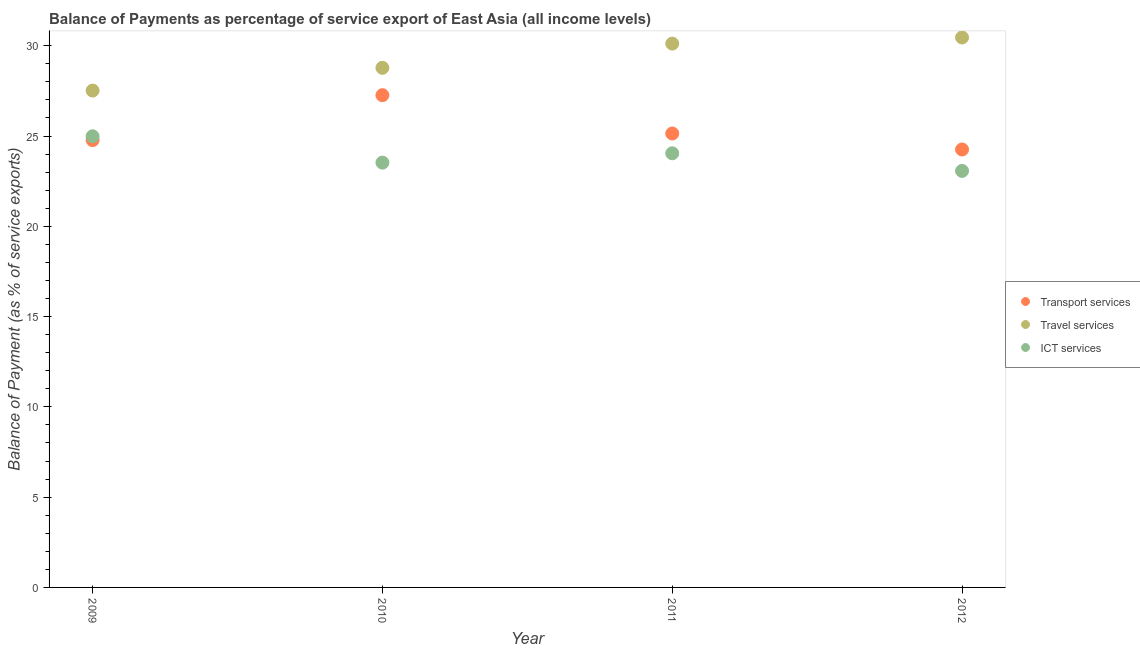How many different coloured dotlines are there?
Your answer should be very brief. 3. Is the number of dotlines equal to the number of legend labels?
Keep it short and to the point. Yes. What is the balance of payment of ict services in 2011?
Make the answer very short. 24.04. Across all years, what is the maximum balance of payment of travel services?
Your answer should be very brief. 30.46. Across all years, what is the minimum balance of payment of travel services?
Provide a short and direct response. 27.51. What is the total balance of payment of ict services in the graph?
Offer a very short reply. 95.62. What is the difference between the balance of payment of ict services in 2010 and that in 2011?
Your answer should be very brief. -0.52. What is the difference between the balance of payment of travel services in 2010 and the balance of payment of transport services in 2012?
Make the answer very short. 4.52. What is the average balance of payment of transport services per year?
Offer a terse response. 25.36. In the year 2009, what is the difference between the balance of payment of travel services and balance of payment of ict services?
Give a very brief answer. 2.53. In how many years, is the balance of payment of travel services greater than 11 %?
Offer a terse response. 4. What is the ratio of the balance of payment of ict services in 2009 to that in 2011?
Offer a terse response. 1.04. Is the balance of payment of ict services in 2011 less than that in 2012?
Ensure brevity in your answer.  No. What is the difference between the highest and the second highest balance of payment of travel services?
Give a very brief answer. 0.34. What is the difference between the highest and the lowest balance of payment of travel services?
Your answer should be very brief. 2.94. Is the sum of the balance of payment of transport services in 2010 and 2011 greater than the maximum balance of payment of ict services across all years?
Your answer should be very brief. Yes. Is it the case that in every year, the sum of the balance of payment of transport services and balance of payment of travel services is greater than the balance of payment of ict services?
Provide a short and direct response. Yes. Does the balance of payment of ict services monotonically increase over the years?
Your answer should be compact. No. Is the balance of payment of travel services strictly greater than the balance of payment of ict services over the years?
Your response must be concise. Yes. How many years are there in the graph?
Your answer should be compact. 4. What is the difference between two consecutive major ticks on the Y-axis?
Offer a very short reply. 5. Are the values on the major ticks of Y-axis written in scientific E-notation?
Your response must be concise. No. What is the title of the graph?
Make the answer very short. Balance of Payments as percentage of service export of East Asia (all income levels). Does "Tertiary" appear as one of the legend labels in the graph?
Ensure brevity in your answer.  No. What is the label or title of the X-axis?
Provide a short and direct response. Year. What is the label or title of the Y-axis?
Provide a succinct answer. Balance of Payment (as % of service exports). What is the Balance of Payment (as % of service exports) of Transport services in 2009?
Give a very brief answer. 24.77. What is the Balance of Payment (as % of service exports) of Travel services in 2009?
Your response must be concise. 27.51. What is the Balance of Payment (as % of service exports) in ICT services in 2009?
Keep it short and to the point. 24.98. What is the Balance of Payment (as % of service exports) in Transport services in 2010?
Ensure brevity in your answer.  27.26. What is the Balance of Payment (as % of service exports) of Travel services in 2010?
Keep it short and to the point. 28.78. What is the Balance of Payment (as % of service exports) of ICT services in 2010?
Ensure brevity in your answer.  23.53. What is the Balance of Payment (as % of service exports) of Transport services in 2011?
Ensure brevity in your answer.  25.14. What is the Balance of Payment (as % of service exports) of Travel services in 2011?
Keep it short and to the point. 30.12. What is the Balance of Payment (as % of service exports) of ICT services in 2011?
Ensure brevity in your answer.  24.04. What is the Balance of Payment (as % of service exports) of Transport services in 2012?
Your answer should be compact. 24.25. What is the Balance of Payment (as % of service exports) in Travel services in 2012?
Give a very brief answer. 30.46. What is the Balance of Payment (as % of service exports) of ICT services in 2012?
Your answer should be very brief. 23.07. Across all years, what is the maximum Balance of Payment (as % of service exports) of Transport services?
Your response must be concise. 27.26. Across all years, what is the maximum Balance of Payment (as % of service exports) of Travel services?
Your answer should be compact. 30.46. Across all years, what is the maximum Balance of Payment (as % of service exports) in ICT services?
Give a very brief answer. 24.98. Across all years, what is the minimum Balance of Payment (as % of service exports) of Transport services?
Your answer should be compact. 24.25. Across all years, what is the minimum Balance of Payment (as % of service exports) in Travel services?
Offer a terse response. 27.51. Across all years, what is the minimum Balance of Payment (as % of service exports) of ICT services?
Provide a short and direct response. 23.07. What is the total Balance of Payment (as % of service exports) of Transport services in the graph?
Make the answer very short. 101.43. What is the total Balance of Payment (as % of service exports) of Travel services in the graph?
Your answer should be compact. 116.86. What is the total Balance of Payment (as % of service exports) of ICT services in the graph?
Ensure brevity in your answer.  95.62. What is the difference between the Balance of Payment (as % of service exports) of Transport services in 2009 and that in 2010?
Provide a short and direct response. -2.49. What is the difference between the Balance of Payment (as % of service exports) of Travel services in 2009 and that in 2010?
Offer a terse response. -1.26. What is the difference between the Balance of Payment (as % of service exports) in ICT services in 2009 and that in 2010?
Offer a terse response. 1.46. What is the difference between the Balance of Payment (as % of service exports) in Transport services in 2009 and that in 2011?
Your answer should be very brief. -0.37. What is the difference between the Balance of Payment (as % of service exports) in Travel services in 2009 and that in 2011?
Your answer should be compact. -2.6. What is the difference between the Balance of Payment (as % of service exports) of ICT services in 2009 and that in 2011?
Your answer should be compact. 0.94. What is the difference between the Balance of Payment (as % of service exports) in Transport services in 2009 and that in 2012?
Offer a very short reply. 0.52. What is the difference between the Balance of Payment (as % of service exports) of Travel services in 2009 and that in 2012?
Your answer should be compact. -2.94. What is the difference between the Balance of Payment (as % of service exports) in ICT services in 2009 and that in 2012?
Offer a terse response. 1.92. What is the difference between the Balance of Payment (as % of service exports) in Transport services in 2010 and that in 2011?
Provide a short and direct response. 2.12. What is the difference between the Balance of Payment (as % of service exports) in Travel services in 2010 and that in 2011?
Ensure brevity in your answer.  -1.34. What is the difference between the Balance of Payment (as % of service exports) of ICT services in 2010 and that in 2011?
Offer a very short reply. -0.52. What is the difference between the Balance of Payment (as % of service exports) of Transport services in 2010 and that in 2012?
Your response must be concise. 3.01. What is the difference between the Balance of Payment (as % of service exports) in Travel services in 2010 and that in 2012?
Your answer should be compact. -1.68. What is the difference between the Balance of Payment (as % of service exports) of ICT services in 2010 and that in 2012?
Offer a very short reply. 0.46. What is the difference between the Balance of Payment (as % of service exports) in Transport services in 2011 and that in 2012?
Your answer should be very brief. 0.89. What is the difference between the Balance of Payment (as % of service exports) in Travel services in 2011 and that in 2012?
Offer a very short reply. -0.34. What is the difference between the Balance of Payment (as % of service exports) in ICT services in 2011 and that in 2012?
Keep it short and to the point. 0.98. What is the difference between the Balance of Payment (as % of service exports) of Transport services in 2009 and the Balance of Payment (as % of service exports) of Travel services in 2010?
Provide a short and direct response. -4. What is the difference between the Balance of Payment (as % of service exports) of Transport services in 2009 and the Balance of Payment (as % of service exports) of ICT services in 2010?
Provide a succinct answer. 1.25. What is the difference between the Balance of Payment (as % of service exports) of Travel services in 2009 and the Balance of Payment (as % of service exports) of ICT services in 2010?
Give a very brief answer. 3.99. What is the difference between the Balance of Payment (as % of service exports) in Transport services in 2009 and the Balance of Payment (as % of service exports) in Travel services in 2011?
Provide a succinct answer. -5.34. What is the difference between the Balance of Payment (as % of service exports) in Transport services in 2009 and the Balance of Payment (as % of service exports) in ICT services in 2011?
Provide a succinct answer. 0.73. What is the difference between the Balance of Payment (as % of service exports) of Travel services in 2009 and the Balance of Payment (as % of service exports) of ICT services in 2011?
Offer a terse response. 3.47. What is the difference between the Balance of Payment (as % of service exports) in Transport services in 2009 and the Balance of Payment (as % of service exports) in Travel services in 2012?
Make the answer very short. -5.68. What is the difference between the Balance of Payment (as % of service exports) of Transport services in 2009 and the Balance of Payment (as % of service exports) of ICT services in 2012?
Your answer should be compact. 1.71. What is the difference between the Balance of Payment (as % of service exports) of Travel services in 2009 and the Balance of Payment (as % of service exports) of ICT services in 2012?
Your response must be concise. 4.45. What is the difference between the Balance of Payment (as % of service exports) in Transport services in 2010 and the Balance of Payment (as % of service exports) in Travel services in 2011?
Offer a very short reply. -2.86. What is the difference between the Balance of Payment (as % of service exports) in Transport services in 2010 and the Balance of Payment (as % of service exports) in ICT services in 2011?
Offer a terse response. 3.22. What is the difference between the Balance of Payment (as % of service exports) in Travel services in 2010 and the Balance of Payment (as % of service exports) in ICT services in 2011?
Your response must be concise. 4.73. What is the difference between the Balance of Payment (as % of service exports) of Transport services in 2010 and the Balance of Payment (as % of service exports) of Travel services in 2012?
Make the answer very short. -3.19. What is the difference between the Balance of Payment (as % of service exports) of Transport services in 2010 and the Balance of Payment (as % of service exports) of ICT services in 2012?
Give a very brief answer. 4.19. What is the difference between the Balance of Payment (as % of service exports) of Travel services in 2010 and the Balance of Payment (as % of service exports) of ICT services in 2012?
Keep it short and to the point. 5.71. What is the difference between the Balance of Payment (as % of service exports) of Transport services in 2011 and the Balance of Payment (as % of service exports) of Travel services in 2012?
Provide a succinct answer. -5.32. What is the difference between the Balance of Payment (as % of service exports) in Transport services in 2011 and the Balance of Payment (as % of service exports) in ICT services in 2012?
Your answer should be compact. 2.07. What is the difference between the Balance of Payment (as % of service exports) in Travel services in 2011 and the Balance of Payment (as % of service exports) in ICT services in 2012?
Your answer should be very brief. 7.05. What is the average Balance of Payment (as % of service exports) of Transport services per year?
Your answer should be compact. 25.36. What is the average Balance of Payment (as % of service exports) in Travel services per year?
Offer a very short reply. 29.22. What is the average Balance of Payment (as % of service exports) of ICT services per year?
Your answer should be compact. 23.9. In the year 2009, what is the difference between the Balance of Payment (as % of service exports) in Transport services and Balance of Payment (as % of service exports) in Travel services?
Your answer should be compact. -2.74. In the year 2009, what is the difference between the Balance of Payment (as % of service exports) of Transport services and Balance of Payment (as % of service exports) of ICT services?
Ensure brevity in your answer.  -0.21. In the year 2009, what is the difference between the Balance of Payment (as % of service exports) of Travel services and Balance of Payment (as % of service exports) of ICT services?
Ensure brevity in your answer.  2.53. In the year 2010, what is the difference between the Balance of Payment (as % of service exports) of Transport services and Balance of Payment (as % of service exports) of Travel services?
Give a very brief answer. -1.51. In the year 2010, what is the difference between the Balance of Payment (as % of service exports) in Transport services and Balance of Payment (as % of service exports) in ICT services?
Provide a short and direct response. 3.74. In the year 2010, what is the difference between the Balance of Payment (as % of service exports) in Travel services and Balance of Payment (as % of service exports) in ICT services?
Your response must be concise. 5.25. In the year 2011, what is the difference between the Balance of Payment (as % of service exports) in Transport services and Balance of Payment (as % of service exports) in Travel services?
Ensure brevity in your answer.  -4.98. In the year 2011, what is the difference between the Balance of Payment (as % of service exports) of Transport services and Balance of Payment (as % of service exports) of ICT services?
Provide a succinct answer. 1.1. In the year 2011, what is the difference between the Balance of Payment (as % of service exports) in Travel services and Balance of Payment (as % of service exports) in ICT services?
Make the answer very short. 6.08. In the year 2012, what is the difference between the Balance of Payment (as % of service exports) of Transport services and Balance of Payment (as % of service exports) of Travel services?
Offer a very short reply. -6.2. In the year 2012, what is the difference between the Balance of Payment (as % of service exports) in Transport services and Balance of Payment (as % of service exports) in ICT services?
Provide a succinct answer. 1.19. In the year 2012, what is the difference between the Balance of Payment (as % of service exports) of Travel services and Balance of Payment (as % of service exports) of ICT services?
Ensure brevity in your answer.  7.39. What is the ratio of the Balance of Payment (as % of service exports) of Transport services in 2009 to that in 2010?
Your answer should be very brief. 0.91. What is the ratio of the Balance of Payment (as % of service exports) in Travel services in 2009 to that in 2010?
Offer a terse response. 0.96. What is the ratio of the Balance of Payment (as % of service exports) of ICT services in 2009 to that in 2010?
Offer a very short reply. 1.06. What is the ratio of the Balance of Payment (as % of service exports) of Transport services in 2009 to that in 2011?
Your answer should be very brief. 0.99. What is the ratio of the Balance of Payment (as % of service exports) of Travel services in 2009 to that in 2011?
Your answer should be compact. 0.91. What is the ratio of the Balance of Payment (as % of service exports) of ICT services in 2009 to that in 2011?
Your response must be concise. 1.04. What is the ratio of the Balance of Payment (as % of service exports) of Transport services in 2009 to that in 2012?
Offer a very short reply. 1.02. What is the ratio of the Balance of Payment (as % of service exports) of Travel services in 2009 to that in 2012?
Offer a terse response. 0.9. What is the ratio of the Balance of Payment (as % of service exports) in ICT services in 2009 to that in 2012?
Your answer should be compact. 1.08. What is the ratio of the Balance of Payment (as % of service exports) in Transport services in 2010 to that in 2011?
Keep it short and to the point. 1.08. What is the ratio of the Balance of Payment (as % of service exports) of Travel services in 2010 to that in 2011?
Make the answer very short. 0.96. What is the ratio of the Balance of Payment (as % of service exports) in ICT services in 2010 to that in 2011?
Offer a very short reply. 0.98. What is the ratio of the Balance of Payment (as % of service exports) of Transport services in 2010 to that in 2012?
Provide a succinct answer. 1.12. What is the ratio of the Balance of Payment (as % of service exports) in Travel services in 2010 to that in 2012?
Your answer should be very brief. 0.94. What is the ratio of the Balance of Payment (as % of service exports) in ICT services in 2010 to that in 2012?
Your answer should be compact. 1.02. What is the ratio of the Balance of Payment (as % of service exports) of Transport services in 2011 to that in 2012?
Your answer should be very brief. 1.04. What is the ratio of the Balance of Payment (as % of service exports) in Travel services in 2011 to that in 2012?
Your answer should be very brief. 0.99. What is the ratio of the Balance of Payment (as % of service exports) in ICT services in 2011 to that in 2012?
Offer a terse response. 1.04. What is the difference between the highest and the second highest Balance of Payment (as % of service exports) of Transport services?
Ensure brevity in your answer.  2.12. What is the difference between the highest and the second highest Balance of Payment (as % of service exports) in Travel services?
Provide a succinct answer. 0.34. What is the difference between the highest and the second highest Balance of Payment (as % of service exports) of ICT services?
Provide a short and direct response. 0.94. What is the difference between the highest and the lowest Balance of Payment (as % of service exports) of Transport services?
Make the answer very short. 3.01. What is the difference between the highest and the lowest Balance of Payment (as % of service exports) of Travel services?
Your answer should be compact. 2.94. What is the difference between the highest and the lowest Balance of Payment (as % of service exports) in ICT services?
Your response must be concise. 1.92. 